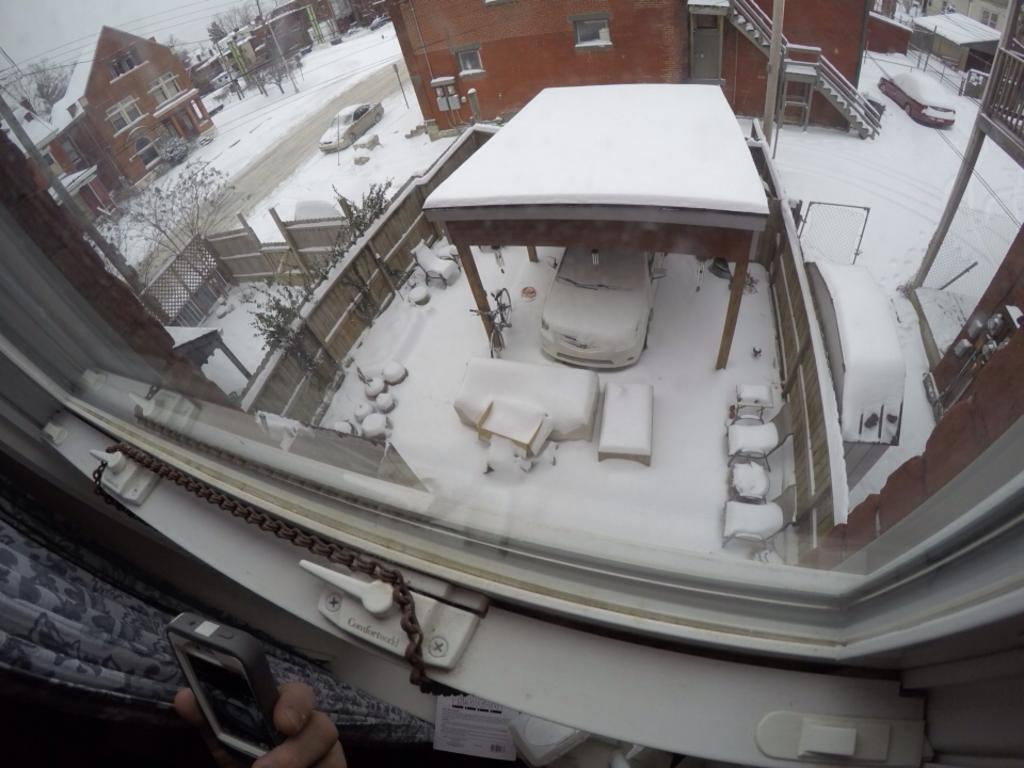Can you describe this image briefly? In this image, we can see a person's hand who is holding a device and in front of the person there is a window and also a curtain. Behind the window, there is a shed covered with snow and a car is parked in that shed and the ground is completely covered with snow. There are houses with snow on them and few cars parked on the road. 